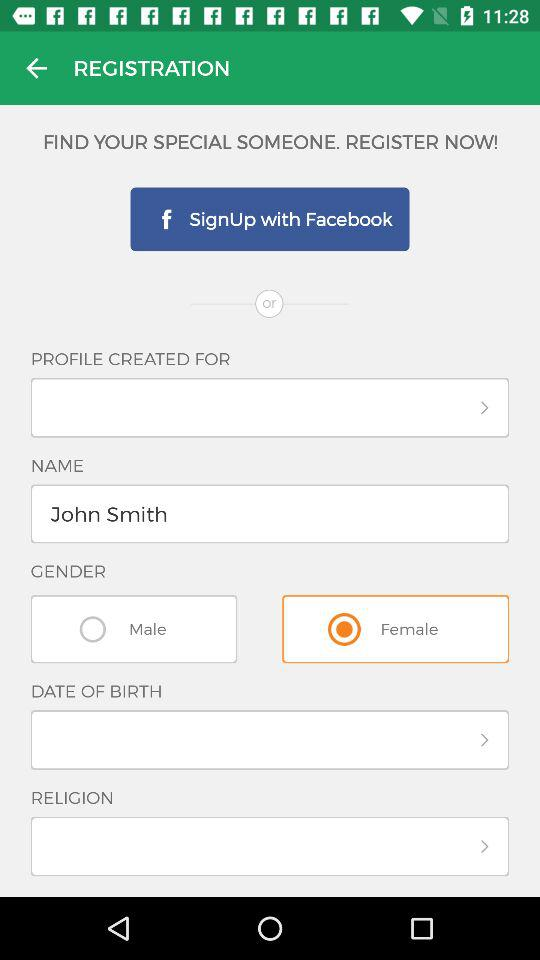What is the typed name? The typed name is John Smith. 